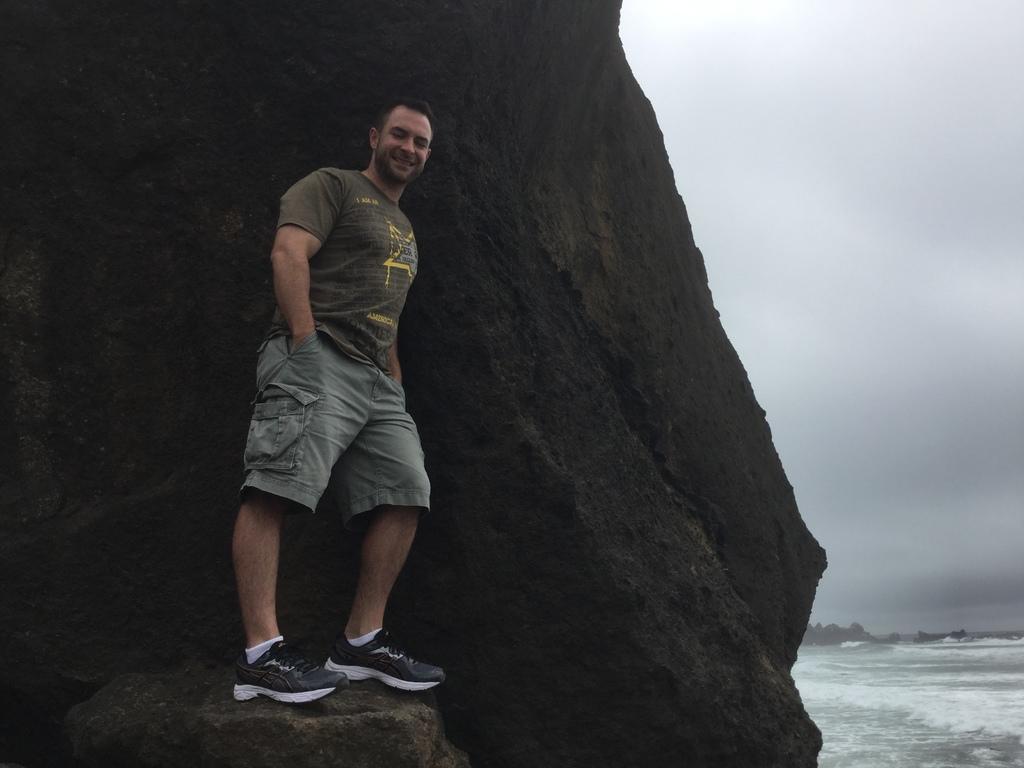Could you give a brief overview of what you see in this image? On the left side we can see a man is standing on the stone at the rock and on the right side we can see water, trees and clouds in the sky. 